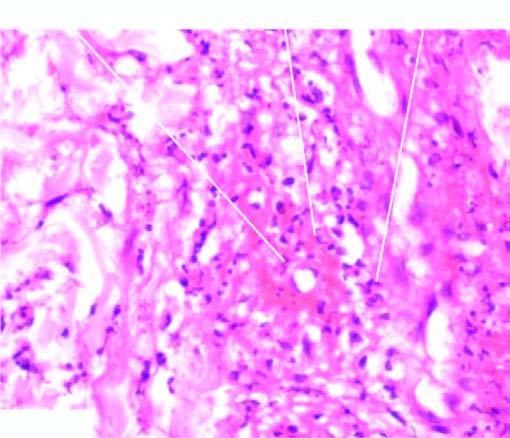does the vesselwall show brightly pink amorphous material and nuclear fragments of necrosed neutrophils?
Answer the question using a single word or phrase. Yes 